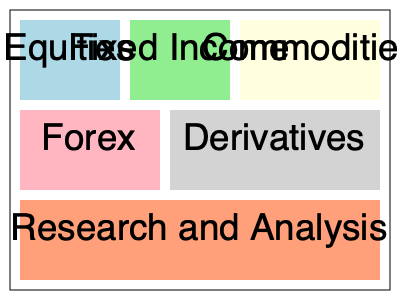As a stock trader focused on fundamental analysis, you're tasked with optimizing the trading floor layout. The current layout is shown above, with different sections for various asset classes and a research area. Which two sections would you recommend placing adjacent to each other to improve efficiency for a trader primarily dealing with equities and using fundamental analysis? To answer this question, we need to consider the workflow of a stock trader who relies on fundamental analysis:

1. Fundamental analysis involves studying company financials, industry trends, and economic indicators.
2. This type of analysis often requires in-depth research and access to various data sources.
3. For a stock trader primarily dealing with equities, the most relevant sections are:
   a) Equities trading desk
   b) Research and Analysis area

4. The current layout shows:
   - Equities section in the top-left corner
   - Research and Analysis section at the bottom

5. Placing these two sections adjacent to each other would allow the trader to:
   a) Quickly move between research and trading activities
   b) Easily communicate findings with colleagues
   c) Reduce time spent moving across the trading floor

6. The most efficient arrangement would be to move the Equities section next to the Research and Analysis section.

7. This could be achieved by swapping the positions of the Equities and Forex sections, placing Equities directly above Research and Analysis.
Answer: Equities and Research and Analysis 